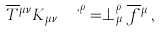Convert formula to latex. <formula><loc_0><loc_0><loc_500><loc_500>\overline { T } { ^ { \mu \nu } } K _ { \mu \nu } ^ { \quad , \rho } = \perp _ { \, \mu } ^ { \, \rho } \overline { f } { ^ { \mu } } \, ,</formula> 